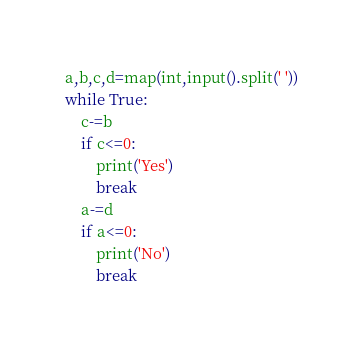Convert code to text. <code><loc_0><loc_0><loc_500><loc_500><_Python_>a,b,c,d=map(int,input().split(' '))
while True:
    c-=b
    if c<=0:
        print('Yes')
        break
    a-=d
    if a<=0:
        print('No')
        break</code> 